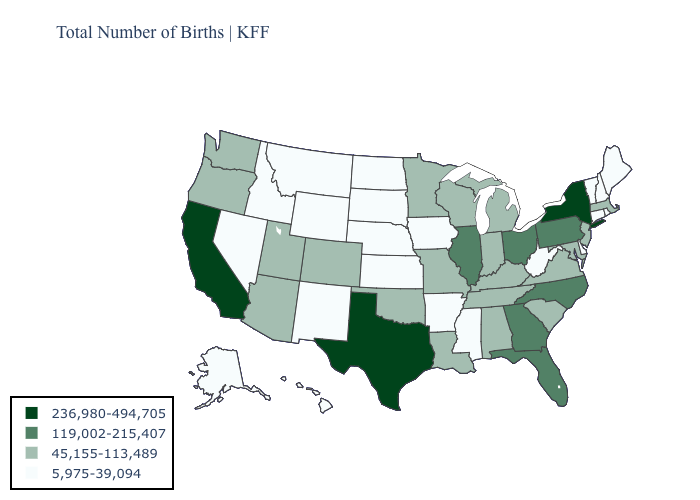Does the map have missing data?
Write a very short answer. No. Which states have the lowest value in the West?
Be succinct. Alaska, Hawaii, Idaho, Montana, Nevada, New Mexico, Wyoming. Among the states that border Alabama , does Mississippi have the lowest value?
Short answer required. Yes. What is the value of Kansas?
Short answer required. 5,975-39,094. Name the states that have a value in the range 45,155-113,489?
Be succinct. Alabama, Arizona, Colorado, Indiana, Kentucky, Louisiana, Maryland, Massachusetts, Michigan, Minnesota, Missouri, New Jersey, Oklahoma, Oregon, South Carolina, Tennessee, Utah, Virginia, Washington, Wisconsin. Does California have a higher value than Pennsylvania?
Quick response, please. Yes. Does New Jersey have the highest value in the USA?
Concise answer only. No. Does Wyoming have the highest value in the West?
Concise answer only. No. What is the highest value in the USA?
Short answer required. 236,980-494,705. What is the highest value in states that border South Dakota?
Give a very brief answer. 45,155-113,489. What is the highest value in the USA?
Quick response, please. 236,980-494,705. Name the states that have a value in the range 45,155-113,489?
Keep it brief. Alabama, Arizona, Colorado, Indiana, Kentucky, Louisiana, Maryland, Massachusetts, Michigan, Minnesota, Missouri, New Jersey, Oklahoma, Oregon, South Carolina, Tennessee, Utah, Virginia, Washington, Wisconsin. Name the states that have a value in the range 45,155-113,489?
Quick response, please. Alabama, Arizona, Colorado, Indiana, Kentucky, Louisiana, Maryland, Massachusetts, Michigan, Minnesota, Missouri, New Jersey, Oklahoma, Oregon, South Carolina, Tennessee, Utah, Virginia, Washington, Wisconsin. Which states have the highest value in the USA?
Short answer required. California, New York, Texas. Name the states that have a value in the range 45,155-113,489?
Give a very brief answer. Alabama, Arizona, Colorado, Indiana, Kentucky, Louisiana, Maryland, Massachusetts, Michigan, Minnesota, Missouri, New Jersey, Oklahoma, Oregon, South Carolina, Tennessee, Utah, Virginia, Washington, Wisconsin. 